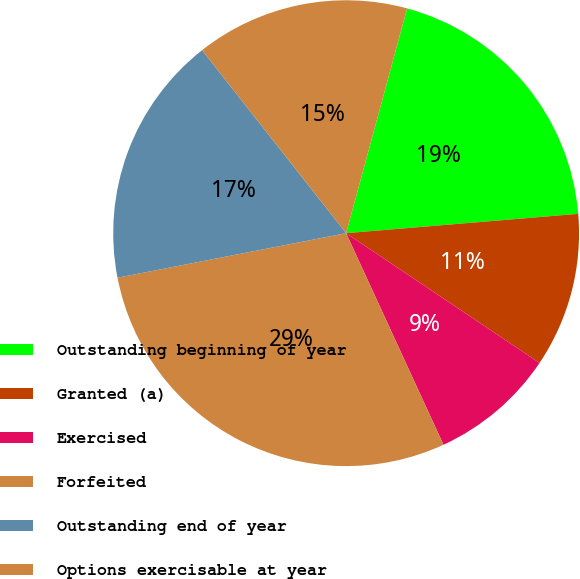<chart> <loc_0><loc_0><loc_500><loc_500><pie_chart><fcel>Outstanding beginning of year<fcel>Granted (a)<fcel>Exercised<fcel>Forfeited<fcel>Outstanding end of year<fcel>Options exercisable at year<nl><fcel>19.46%<fcel>10.73%<fcel>8.73%<fcel>28.8%<fcel>17.45%<fcel>14.83%<nl></chart> 